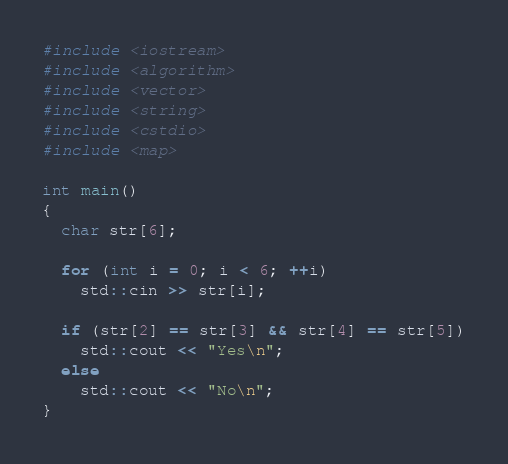<code> <loc_0><loc_0><loc_500><loc_500><_C++_>#include <iostream>
#include <algorithm>
#include <vector>
#include <string>
#include <cstdio>
#include <map>

int main()
{
  char str[6];

  for (int i = 0; i < 6; ++i)
    std::cin >> str[i];

  if (str[2] == str[3] && str[4] == str[5])
    std::cout << "Yes\n";
  else
    std::cout << "No\n";
}</code> 